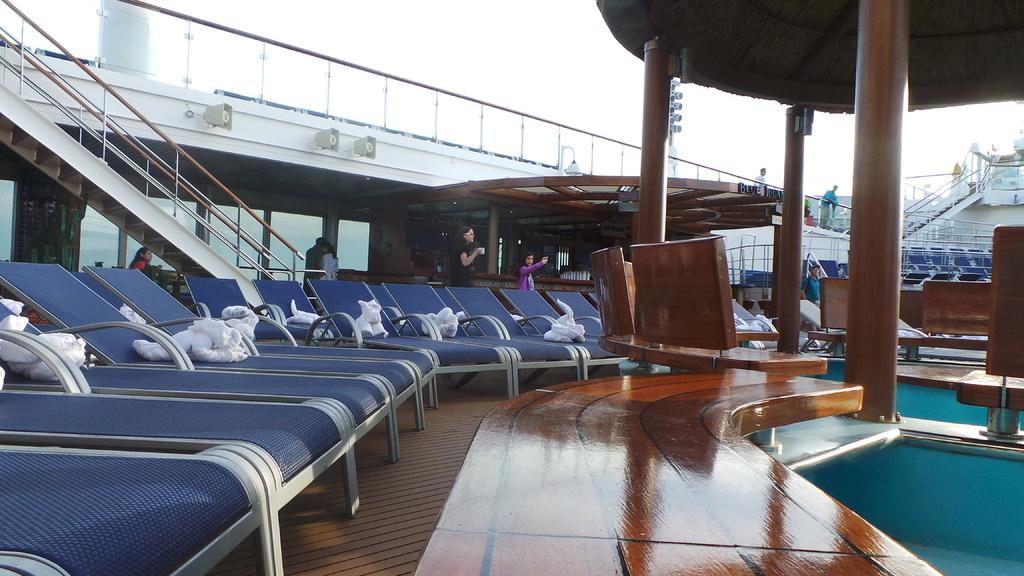What type of furniture can be seen on the floor in the image? There are chairs on the floor in the image. What architectural features are present in the image? There are pillars, staircases, and railings in the image. What type of audio equipment is visible in the image? There are speakers in the image. What can be used for ventilation or viewing the outdoors in the image? There are windows in the image. How many people are present in the image? There are people in the image. What other objects can be seen in the image besides the chairs and speakers? There are objects in the image. What is visible in the background of the image? The sky is visible in the background of the image. Can you tell me how many ladybugs are crawling on the chairs in the image? There are no ladybugs present in the image; it features chairs, pillars, staircases, railings, speakers, windows, people, and objects. What type of weapon is being fired by the grandmother in the image? There is no grandmother or weapon present in the image. 